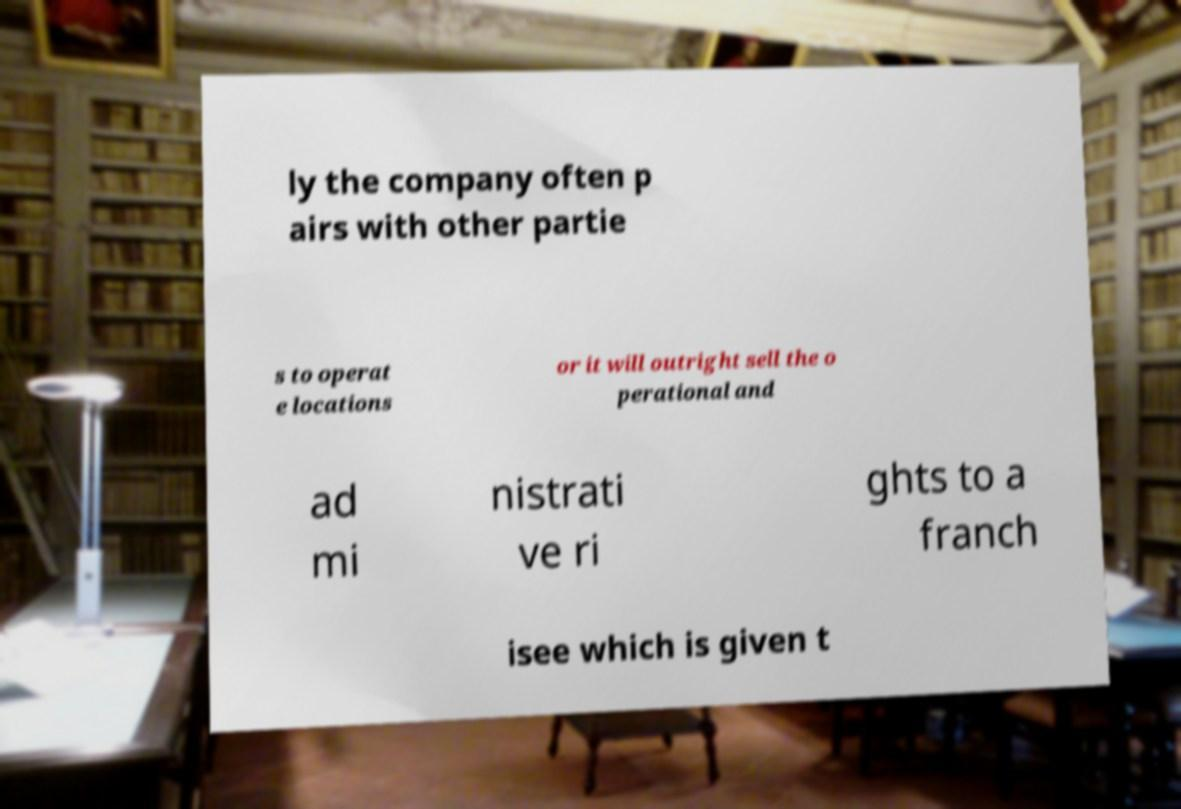Please read and relay the text visible in this image. What does it say? ly the company often p airs with other partie s to operat e locations or it will outright sell the o perational and ad mi nistrati ve ri ghts to a franch isee which is given t 